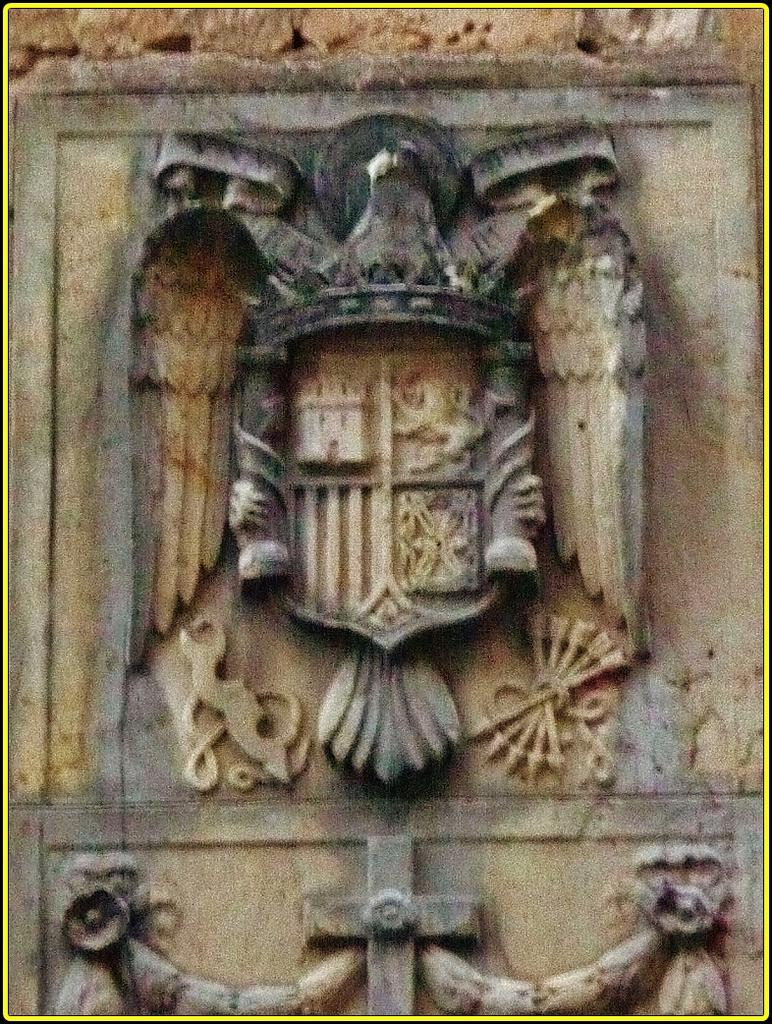What is the main subject of the image? There is a sculpture in the image. How many dogs are visible in the image? There are no dogs present in the image; it features a sculpture. What type of planes can be seen flying in the image? There are no planes present in the image; it features a sculpture. 